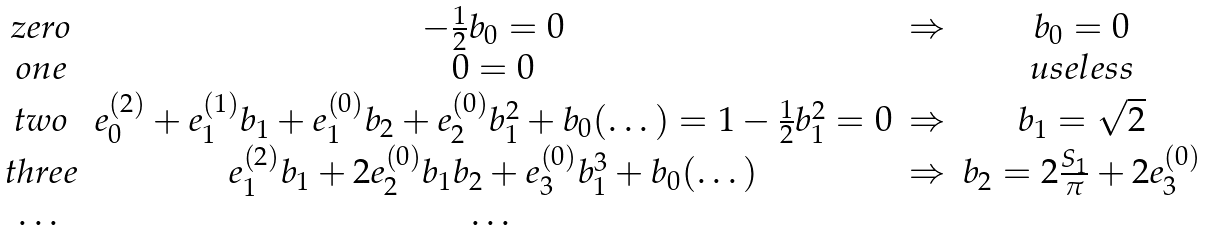Convert formula to latex. <formula><loc_0><loc_0><loc_500><loc_500>\begin{array} { c c c c } z e r o & - \frac { 1 } { 2 } b _ { 0 } = 0 & \Rightarrow & b _ { 0 } = 0 \\ o n e & 0 = 0 & & u s e l e s s \\ t w o & e _ { 0 } ^ { ( 2 ) } + e _ { 1 } ^ { ( 1 ) } b _ { 1 } + e _ { 1 } ^ { ( 0 ) } b _ { 2 } + e _ { 2 } ^ { ( 0 ) } b _ { 1 } ^ { 2 } + b _ { 0 } ( \dots ) = 1 - \frac { 1 } { 2 } b _ { 1 } ^ { 2 } = 0 & \Rightarrow & b _ { 1 } = \sqrt { 2 } \\ t h r e e & e _ { 1 } ^ { ( 2 ) } b _ { 1 } + 2 e _ { 2 } ^ { ( 0 ) } b _ { 1 } b _ { 2 } + e _ { 3 } ^ { ( 0 ) } b _ { 1 } ^ { 3 } + b _ { 0 } ( \dots ) & \Rightarrow & b _ { 2 } = 2 \frac { S _ { 1 } } { \pi } + 2 e _ { 3 } ^ { ( 0 ) } \\ \dots & \dots & & \end{array}</formula> 